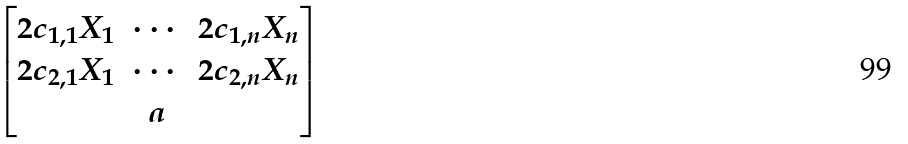Convert formula to latex. <formula><loc_0><loc_0><loc_500><loc_500>\begin{bmatrix} 2 c _ { 1 , 1 } X _ { 1 } & \cdots & 2 c _ { 1 , n } X _ { n } \\ 2 c _ { 2 , 1 } X _ { 1 } & \cdots & 2 c _ { 2 , n } X _ { n } \\ & a & \end{bmatrix}</formula> 